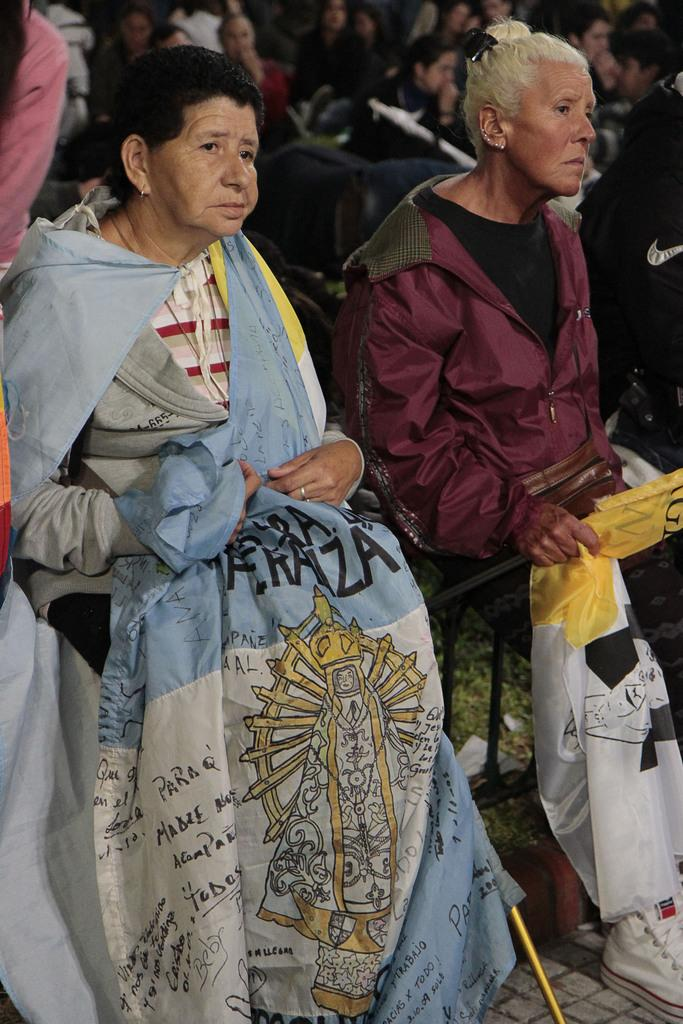What is the main subject in the foreground of the image? There is a woman holding a flag in the foreground of the image. Are there any other people holding flags in the image? Yes, there is another woman sitting and holding a flag beside the first woman. What can be seen in the background of the image? There are people in the background of the image. What type of pain is the woman experiencing while holding the flag in the image? There is no indication in the image that the woman is experiencing any pain, so it cannot be determined from the picture. 